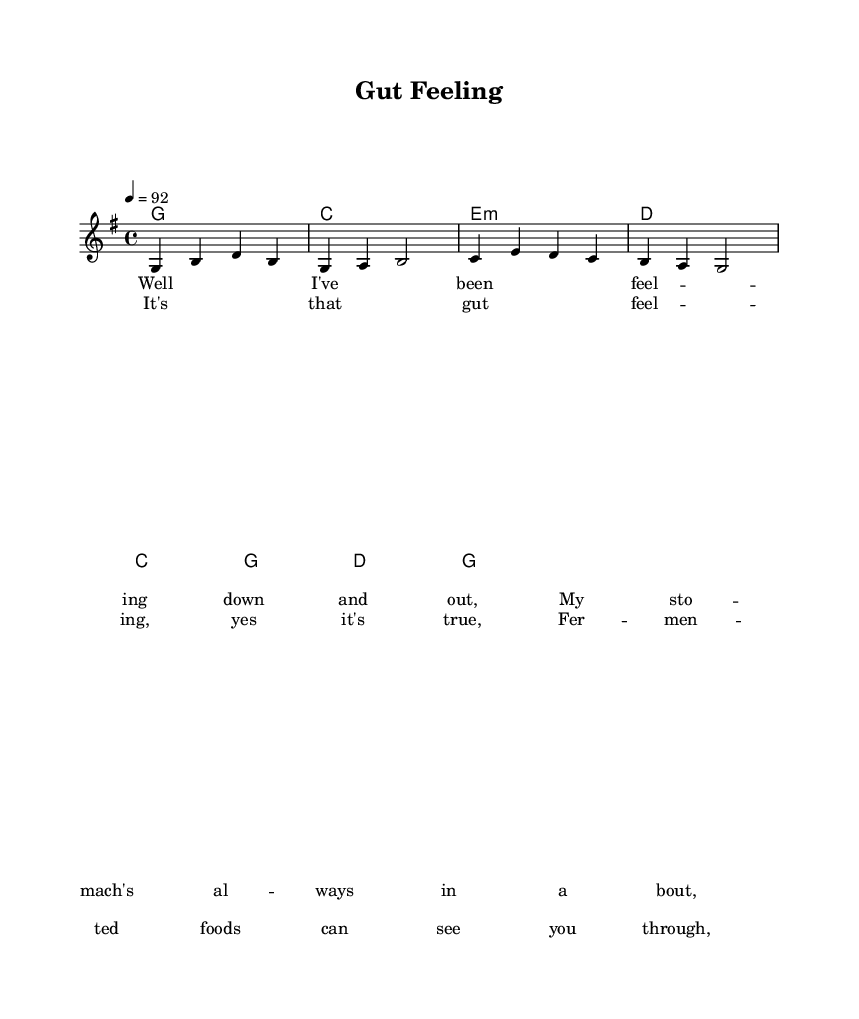What is the key signature of this music? The key signature indicated is G major, which has one sharp (F#). This can be identified at the beginning of the score where the key signature is shown.
Answer: G major What is the time signature of this music? The time signature is 4/4, indicated at the start of the score. This means there are four beats per measure and the quarter note receives one beat.
Answer: 4/4 What is the tempo marking of this music? The tempo marking shows a tempo of 92 beats per minute, which is indicated as "4 = 92" at the beginning, dictating how fast the music should be played.
Answer: 92 How many measures are in the melody? The melody consists of 8 measures, which is evident by counting the measures in the provided melody section.
Answer: 8 What is the first lyric line in the verse? The first lyric line in the verse is "Well I've been feel -- ing down and out," which is taken directly from the verseOne section of the lyrics provided.
Answer: Well I've been feel -- ing down and out What chord follows the second measure of the melody? The chord that follows the second measure is C major, found in the harmonies section directly after the first chord G major.
Answer: C What is the theme of the chorus lyrics? The theme of the chorus lyrics discusses how fermented foods can improve gut health, which is the main message expressed in the lines "It's that gut feel -- ing, yes it's true, Fer -- men -- ted foods can see you through."
Answer: Fermented foods and gut health 